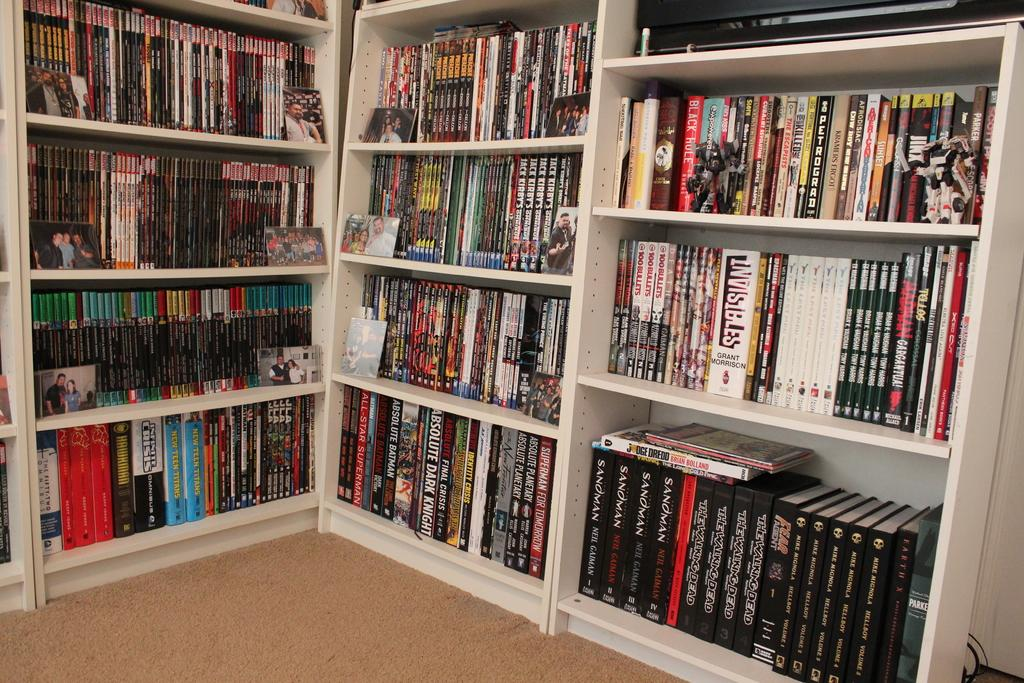<image>
Present a compact description of the photo's key features. Media shelves full of many things including boxed sets of The Walking Dead. 